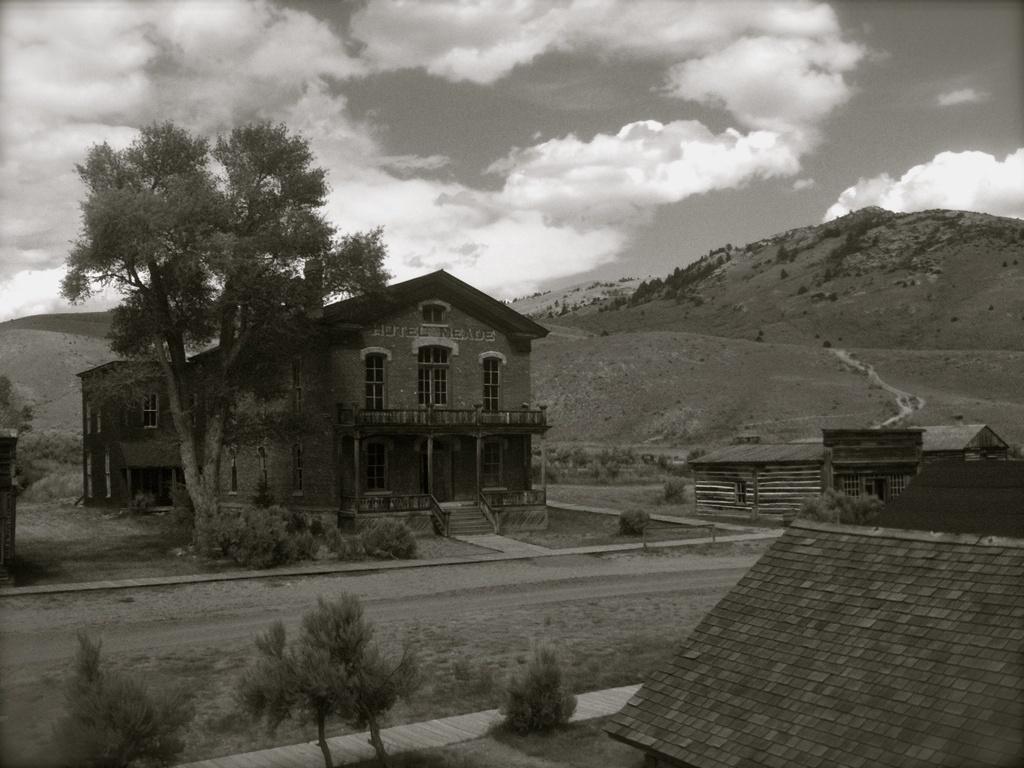Could you give a brief overview of what you see in this image? In this picture I can see there is a building here and there is a tree and there is a mountain in the backdrop and the sky is clear. 